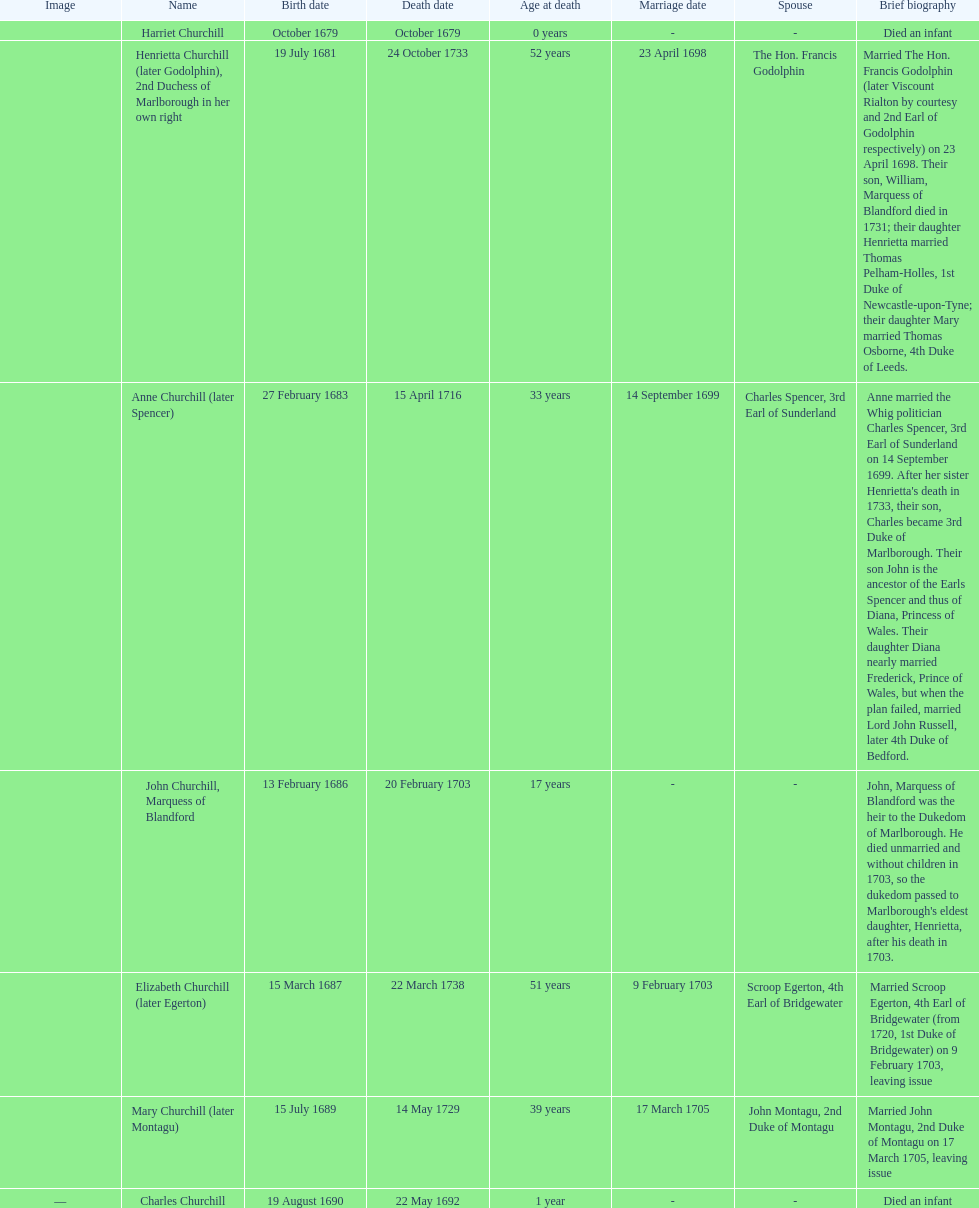What is the number of children sarah churchill had? 7. 